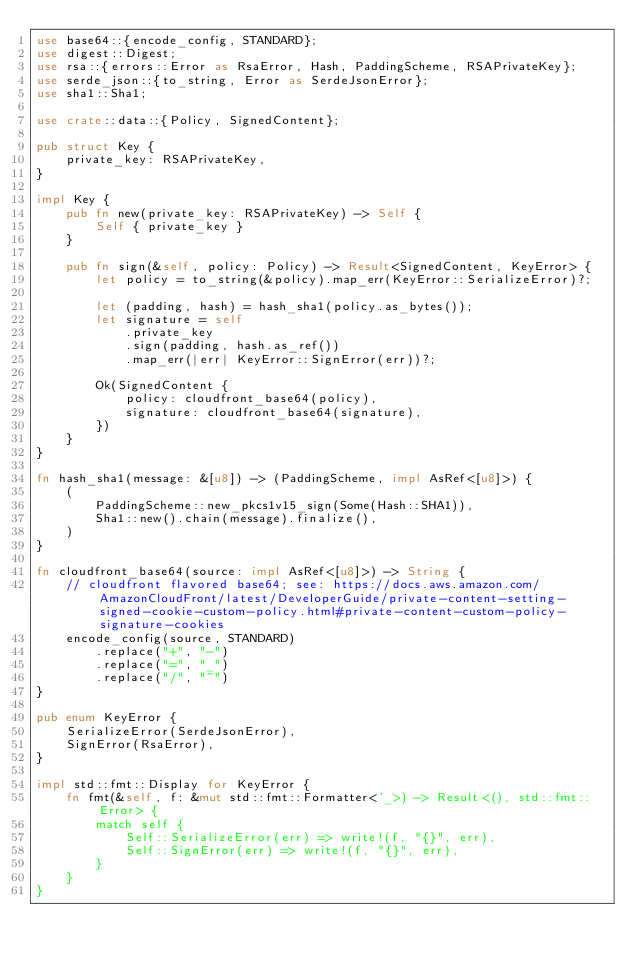<code> <loc_0><loc_0><loc_500><loc_500><_Rust_>use base64::{encode_config, STANDARD};
use digest::Digest;
use rsa::{errors::Error as RsaError, Hash, PaddingScheme, RSAPrivateKey};
use serde_json::{to_string, Error as SerdeJsonError};
use sha1::Sha1;

use crate::data::{Policy, SignedContent};

pub struct Key {
    private_key: RSAPrivateKey,
}

impl Key {
    pub fn new(private_key: RSAPrivateKey) -> Self {
        Self { private_key }
    }

    pub fn sign(&self, policy: Policy) -> Result<SignedContent, KeyError> {
        let policy = to_string(&policy).map_err(KeyError::SerializeError)?;

        let (padding, hash) = hash_sha1(policy.as_bytes());
        let signature = self
            .private_key
            .sign(padding, hash.as_ref())
            .map_err(|err| KeyError::SignError(err))?;

        Ok(SignedContent {
            policy: cloudfront_base64(policy),
            signature: cloudfront_base64(signature),
        })
    }
}

fn hash_sha1(message: &[u8]) -> (PaddingScheme, impl AsRef<[u8]>) {
    (
        PaddingScheme::new_pkcs1v15_sign(Some(Hash::SHA1)),
        Sha1::new().chain(message).finalize(),
    )
}

fn cloudfront_base64(source: impl AsRef<[u8]>) -> String {
    // cloudfront flavored base64; see: https://docs.aws.amazon.com/AmazonCloudFront/latest/DeveloperGuide/private-content-setting-signed-cookie-custom-policy.html#private-content-custom-policy-signature-cookies
    encode_config(source, STANDARD)
        .replace("+", "-")
        .replace("=", "_")
        .replace("/", "~")
}

pub enum KeyError {
    SerializeError(SerdeJsonError),
    SignError(RsaError),
}

impl std::fmt::Display for KeyError {
    fn fmt(&self, f: &mut std::fmt::Formatter<'_>) -> Result<(), std::fmt::Error> {
        match self {
            Self::SerializeError(err) => write!(f, "{}", err),
            Self::SignError(err) => write!(f, "{}", err),
        }
    }
}
</code> 